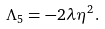Convert formula to latex. <formula><loc_0><loc_0><loc_500><loc_500>\Lambda _ { 5 } = - 2 \lambda \eta ^ { 2 } \, .</formula> 